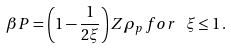<formula> <loc_0><loc_0><loc_500><loc_500>\beta P = \left ( 1 - \frac { 1 } { 2 \xi } \right ) Z \rho _ { p } \, f o r \, \ \xi \leq 1 \, .</formula> 